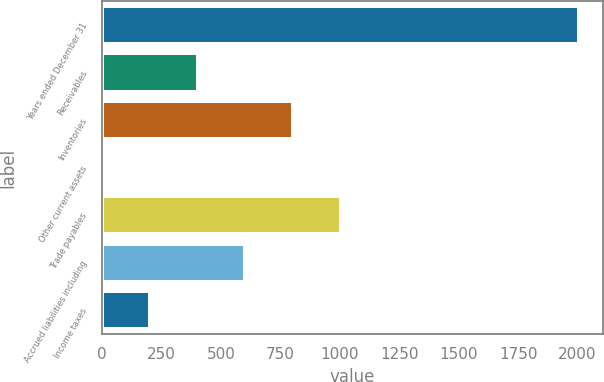Convert chart. <chart><loc_0><loc_0><loc_500><loc_500><bar_chart><fcel>Years ended December 31<fcel>Receivables<fcel>Inventories<fcel>Other current assets<fcel>Trade payables<fcel>Accrued liabilities including<fcel>Income taxes<nl><fcel>2005<fcel>402.04<fcel>802.78<fcel>1.3<fcel>1003.15<fcel>602.41<fcel>201.67<nl></chart> 